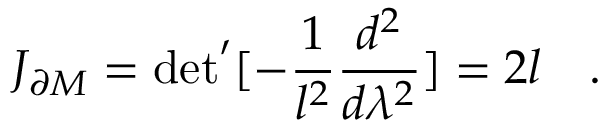Convert formula to latex. <formula><loc_0><loc_0><loc_500><loc_500>J _ { \partial M } = d e t ^ { \prime } [ - { \frac { 1 } { l ^ { 2 } } } { \frac { d ^ { 2 } } { d \lambda ^ { 2 } } } ] = 2 l \quad .</formula> 